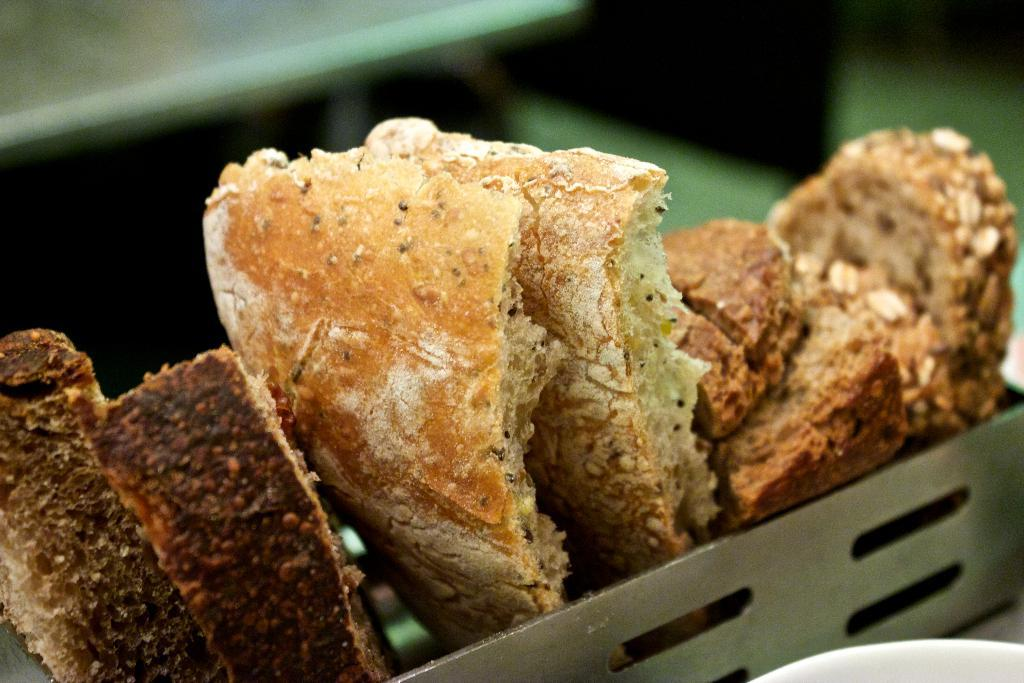What type of container holds the eatable items in the image? There are eatable items in a small steel box. Can you describe the table mentioned in the image? There is a table behind the steel box, although it is not clearly visible. What type of behavior can be observed in the patch on the tail of the animal in the image? There is no animal or patch visible in the image; it only features a small steel box with eatable items and a table in the background. 